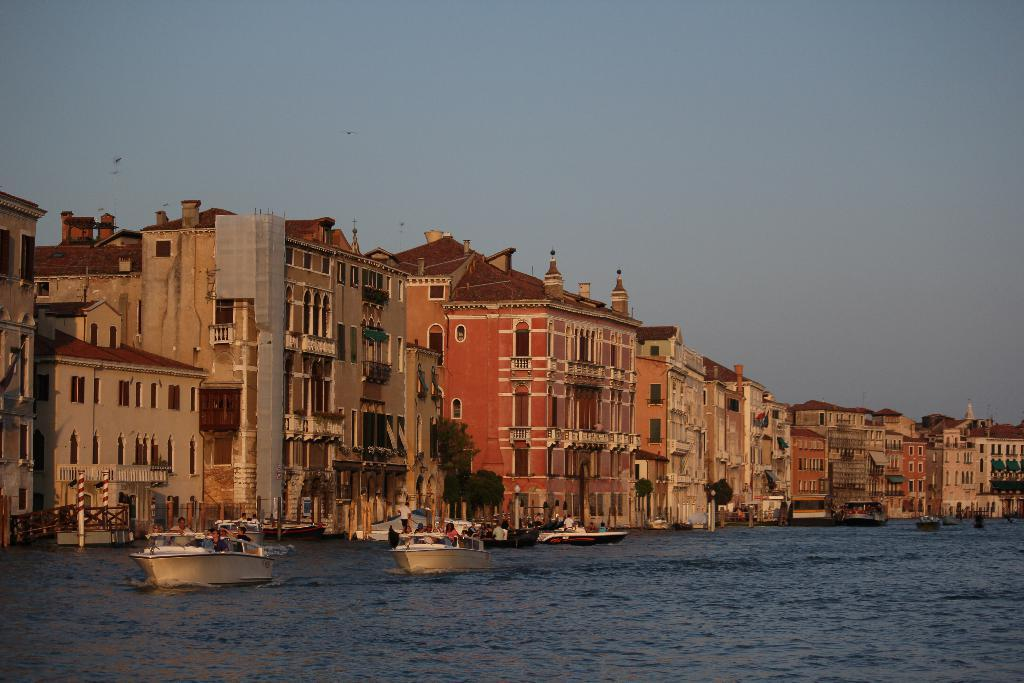What type of structures can be seen in the image? There are buildings in the image. What natural feature is present in the image? There are boats on the water in the image. Where is the hole in the image? There is no hole present in the image. What type of produce can be seen growing in the image? There is no produce visible in the image; it features buildings and boats on the water. 